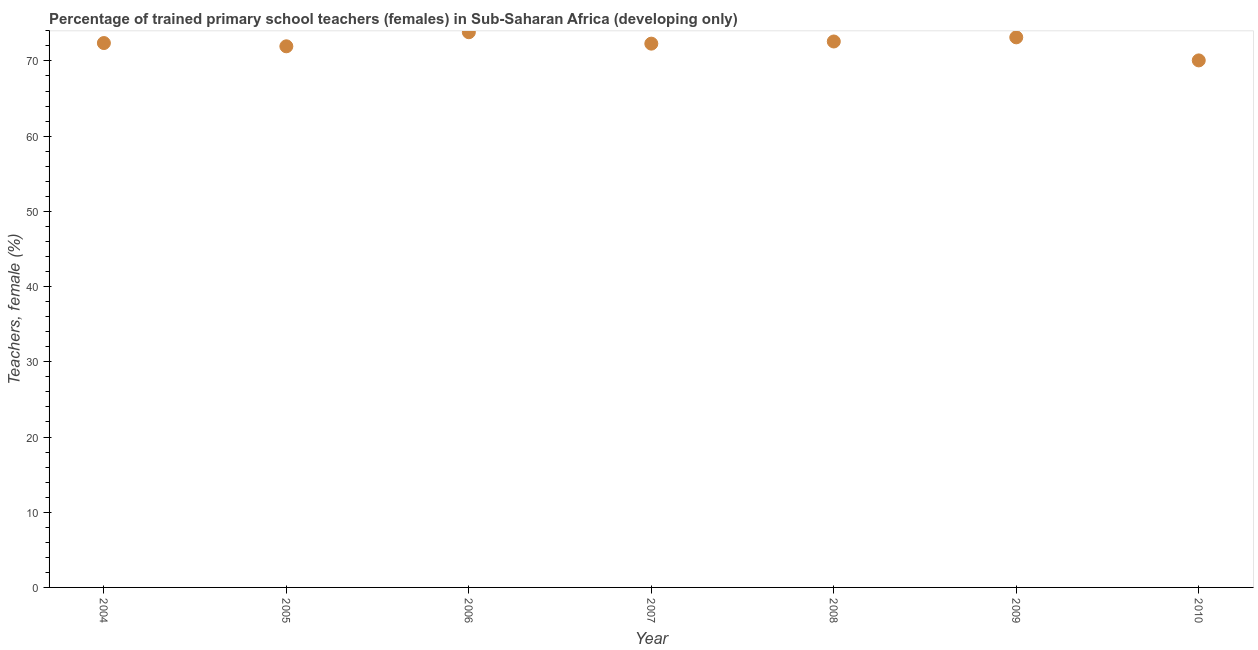What is the percentage of trained female teachers in 2008?
Ensure brevity in your answer.  72.59. Across all years, what is the maximum percentage of trained female teachers?
Ensure brevity in your answer.  73.82. Across all years, what is the minimum percentage of trained female teachers?
Your response must be concise. 70.07. In which year was the percentage of trained female teachers maximum?
Your response must be concise. 2006. What is the sum of the percentage of trained female teachers?
Ensure brevity in your answer.  506.24. What is the difference between the percentage of trained female teachers in 2004 and 2005?
Make the answer very short. 0.43. What is the average percentage of trained female teachers per year?
Ensure brevity in your answer.  72.32. What is the median percentage of trained female teachers?
Keep it short and to the point. 72.38. What is the ratio of the percentage of trained female teachers in 2005 to that in 2009?
Your response must be concise. 0.98. Is the difference between the percentage of trained female teachers in 2006 and 2009 greater than the difference between any two years?
Keep it short and to the point. No. What is the difference between the highest and the second highest percentage of trained female teachers?
Provide a succinct answer. 0.68. What is the difference between the highest and the lowest percentage of trained female teachers?
Offer a very short reply. 3.75. How many years are there in the graph?
Your response must be concise. 7. Are the values on the major ticks of Y-axis written in scientific E-notation?
Offer a terse response. No. Does the graph contain any zero values?
Offer a terse response. No. What is the title of the graph?
Your answer should be very brief. Percentage of trained primary school teachers (females) in Sub-Saharan Africa (developing only). What is the label or title of the X-axis?
Offer a very short reply. Year. What is the label or title of the Y-axis?
Ensure brevity in your answer.  Teachers, female (%). What is the Teachers, female (%) in 2004?
Keep it short and to the point. 72.38. What is the Teachers, female (%) in 2005?
Make the answer very short. 71.95. What is the Teachers, female (%) in 2006?
Provide a short and direct response. 73.82. What is the Teachers, female (%) in 2007?
Make the answer very short. 72.3. What is the Teachers, female (%) in 2008?
Give a very brief answer. 72.59. What is the Teachers, female (%) in 2009?
Offer a terse response. 73.14. What is the Teachers, female (%) in 2010?
Your answer should be very brief. 70.07. What is the difference between the Teachers, female (%) in 2004 and 2005?
Your answer should be very brief. 0.43. What is the difference between the Teachers, female (%) in 2004 and 2006?
Provide a succinct answer. -1.44. What is the difference between the Teachers, female (%) in 2004 and 2007?
Ensure brevity in your answer.  0.08. What is the difference between the Teachers, female (%) in 2004 and 2008?
Give a very brief answer. -0.21. What is the difference between the Teachers, female (%) in 2004 and 2009?
Give a very brief answer. -0.76. What is the difference between the Teachers, female (%) in 2004 and 2010?
Offer a very short reply. 2.31. What is the difference between the Teachers, female (%) in 2005 and 2006?
Offer a terse response. -1.87. What is the difference between the Teachers, female (%) in 2005 and 2007?
Provide a short and direct response. -0.36. What is the difference between the Teachers, female (%) in 2005 and 2008?
Keep it short and to the point. -0.64. What is the difference between the Teachers, female (%) in 2005 and 2009?
Ensure brevity in your answer.  -1.19. What is the difference between the Teachers, female (%) in 2005 and 2010?
Give a very brief answer. 1.87. What is the difference between the Teachers, female (%) in 2006 and 2007?
Make the answer very short. 1.52. What is the difference between the Teachers, female (%) in 2006 and 2008?
Keep it short and to the point. 1.23. What is the difference between the Teachers, female (%) in 2006 and 2009?
Your response must be concise. 0.68. What is the difference between the Teachers, female (%) in 2006 and 2010?
Make the answer very short. 3.75. What is the difference between the Teachers, female (%) in 2007 and 2008?
Offer a terse response. -0.29. What is the difference between the Teachers, female (%) in 2007 and 2009?
Offer a very short reply. -0.84. What is the difference between the Teachers, female (%) in 2007 and 2010?
Offer a very short reply. 2.23. What is the difference between the Teachers, female (%) in 2008 and 2009?
Keep it short and to the point. -0.55. What is the difference between the Teachers, female (%) in 2008 and 2010?
Your response must be concise. 2.51. What is the difference between the Teachers, female (%) in 2009 and 2010?
Give a very brief answer. 3.07. What is the ratio of the Teachers, female (%) in 2004 to that in 2005?
Your response must be concise. 1.01. What is the ratio of the Teachers, female (%) in 2004 to that in 2007?
Provide a succinct answer. 1. What is the ratio of the Teachers, female (%) in 2004 to that in 2009?
Ensure brevity in your answer.  0.99. What is the ratio of the Teachers, female (%) in 2004 to that in 2010?
Your answer should be compact. 1.03. What is the ratio of the Teachers, female (%) in 2005 to that in 2007?
Your answer should be compact. 0.99. What is the ratio of the Teachers, female (%) in 2005 to that in 2008?
Give a very brief answer. 0.99. What is the ratio of the Teachers, female (%) in 2005 to that in 2009?
Keep it short and to the point. 0.98. What is the ratio of the Teachers, female (%) in 2005 to that in 2010?
Offer a very short reply. 1.03. What is the ratio of the Teachers, female (%) in 2006 to that in 2007?
Make the answer very short. 1.02. What is the ratio of the Teachers, female (%) in 2006 to that in 2008?
Make the answer very short. 1.02. What is the ratio of the Teachers, female (%) in 2006 to that in 2009?
Give a very brief answer. 1.01. What is the ratio of the Teachers, female (%) in 2006 to that in 2010?
Ensure brevity in your answer.  1.05. What is the ratio of the Teachers, female (%) in 2007 to that in 2008?
Give a very brief answer. 1. What is the ratio of the Teachers, female (%) in 2007 to that in 2010?
Your answer should be compact. 1.03. What is the ratio of the Teachers, female (%) in 2008 to that in 2010?
Make the answer very short. 1.04. What is the ratio of the Teachers, female (%) in 2009 to that in 2010?
Provide a succinct answer. 1.04. 